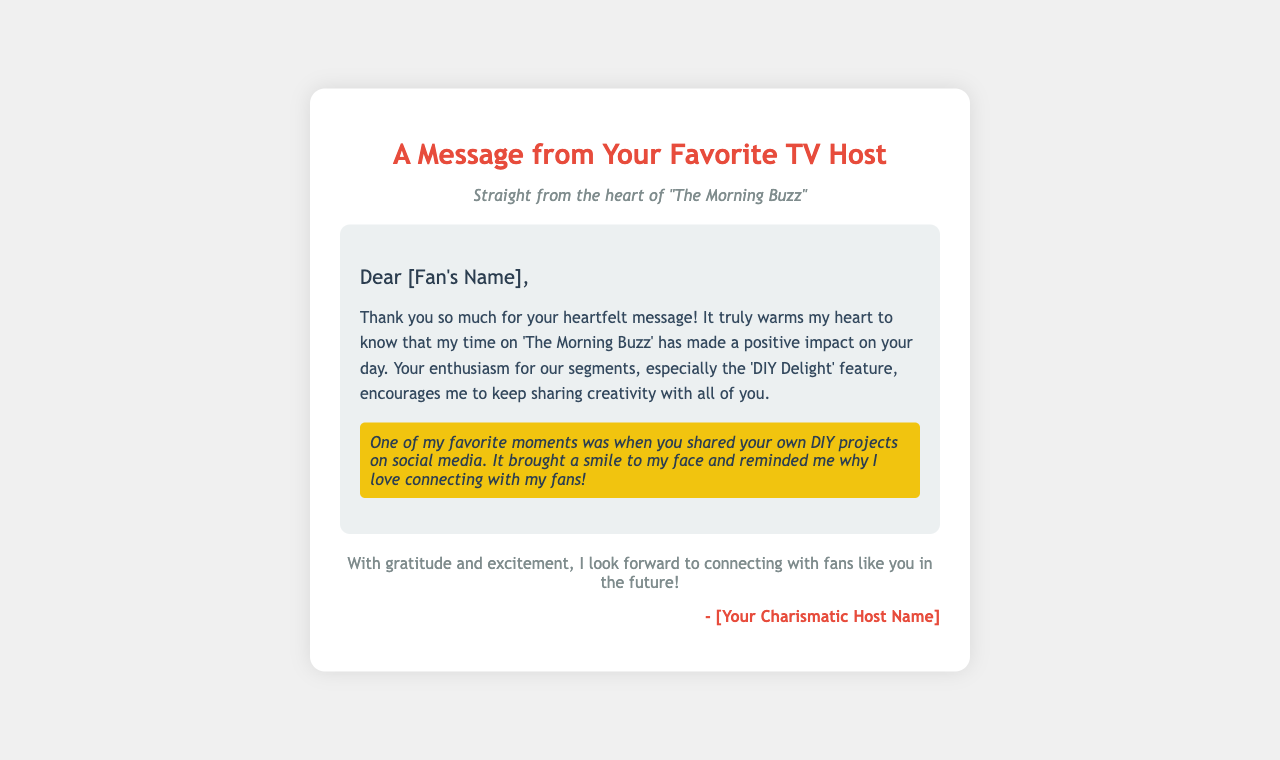What is the title of the document? The title is specified in the `<title>` tag of the HTML document.
Answer: Personalized Fan Mail Response What is the purpose of the message? The purpose is to express gratitude to a fan for their heartfelt message.
Answer: Thank you Which feature is mentioned as a fan favorite? The feature is highlighted as a special segment that resonates with viewers.
Answer: DIY Delight What color is the heading text? The color of the heading text is specified within the CSS styling for the header.
Answer: Red What is included in the highlighted section? The highlighted section shares a specific moment related to the fan's engagement with the host.
Answer: DIY projects How does the host feel about the fan's message? The emotional response to the fan's message is conveyed in the content.
Answer: Warmth What is the main theme of the message? The overarching theme relates to connection and appreciation for viewer interaction.
Answer: Connection Who is the message addressed to? The message is personalized and directed to the intended recipient.
Answer: [Fan's Name] 